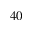<formula> <loc_0><loc_0><loc_500><loc_500>4 0</formula> 